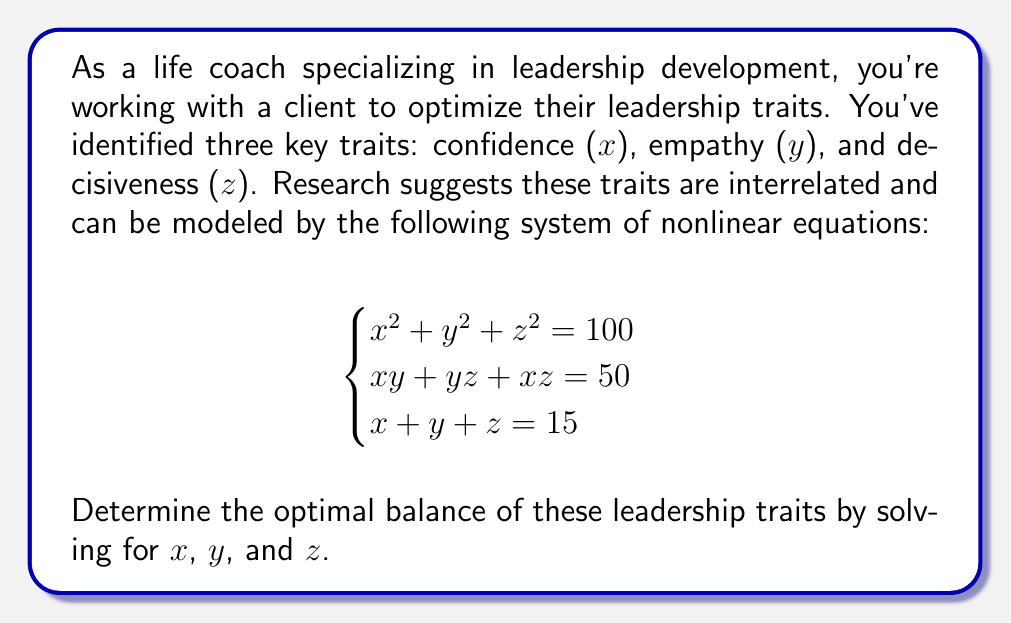Show me your answer to this math problem. Let's approach this step-by-step:

1) We have three equations with three unknowns. Let's start by using the third equation to express $z$ in terms of $x$ and $y$:

   $z = 15 - x - y$

2) Substitute this into the first equation:

   $x^2 + y^2 + (15-x-y)^2 = 100$

3) Expand this:

   $x^2 + y^2 + 225 - 30x - 30y + x^2 + 2xy + y^2 = 100$

4) Simplify:

   $2x^2 + 2y^2 + 2xy - 30x - 30y + 125 = 0$

5) Now, let's use the second equation, again substituting $z = 15 - x - y$:

   $xy + y(15-x-y) + x(15-x-y) = 50$

6) Expand:

   $xy + 15y - xy - y^2 + 15x - x^2 - xy = 50$

7) Simplify:

   $15x + 15y - x^2 - y^2 - xy = 50$

8) Now we have two equations:

   $2x^2 + 2y^2 + 2xy - 30x - 30y + 125 = 0$
   $x^2 + y^2 + xy - 15x - 15y + 50 = 0$

9) Subtract the second equation from the first:

   $x^2 + y^2 + xy - 15x - 15y + 75 = 0$

10) This equation is symmetric in $x$ and $y$, suggesting $x = y$. Let's assume this and substitute back into $x + y + z = 15$:

    $2x + z = 15$
    $z = 15 - 2x$

11) Substitute these into $x^2 + y^2 + z^2 = 100$:

    $x^2 + x^2 + (15-2x)^2 = 100$

12) Expand:

    $2x^2 + 225 - 60x + 4x^2 = 100$

13) Simplify:

    $6x^2 - 60x + 125 = 0$

14) This is a quadratic equation. Solve using the quadratic formula:

    $x = \frac{60 \pm \sqrt{3600 - 3000}}{12} = \frac{60 \pm \sqrt{600}}{12} = 5$

15) Since $x = y = 5$, and $x + y + z = 15$, we can conclude that $z = 5$ as well.

Therefore, the optimal balance is $x = 5$, $y = 5$, and $z = 5$.
Answer: $x = 5$, $y = 5$, $z = 5$ 